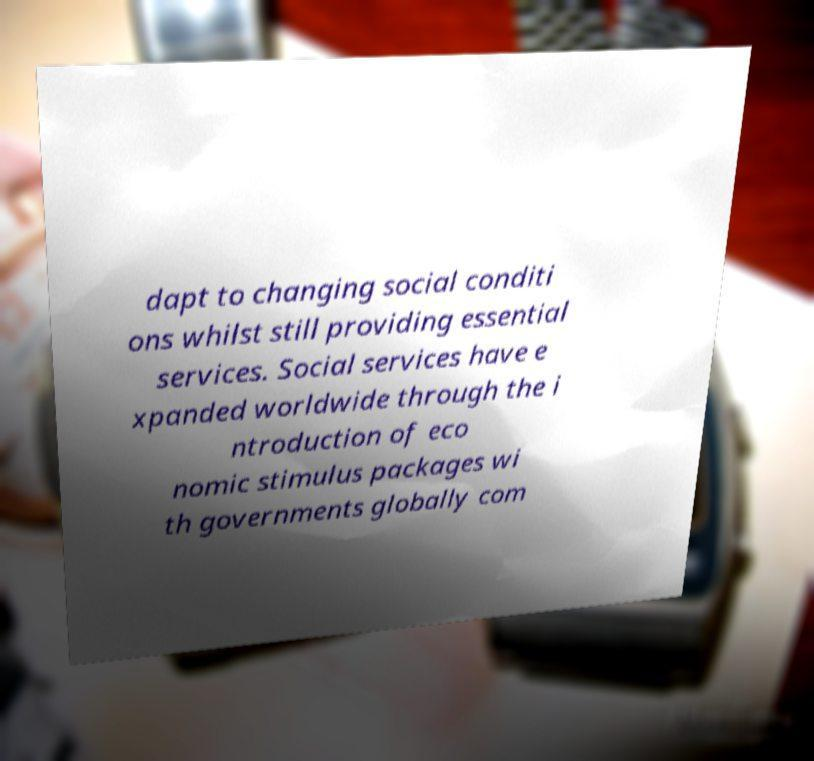What messages or text are displayed in this image? I need them in a readable, typed format. dapt to changing social conditi ons whilst still providing essential services. Social services have e xpanded worldwide through the i ntroduction of eco nomic stimulus packages wi th governments globally com 